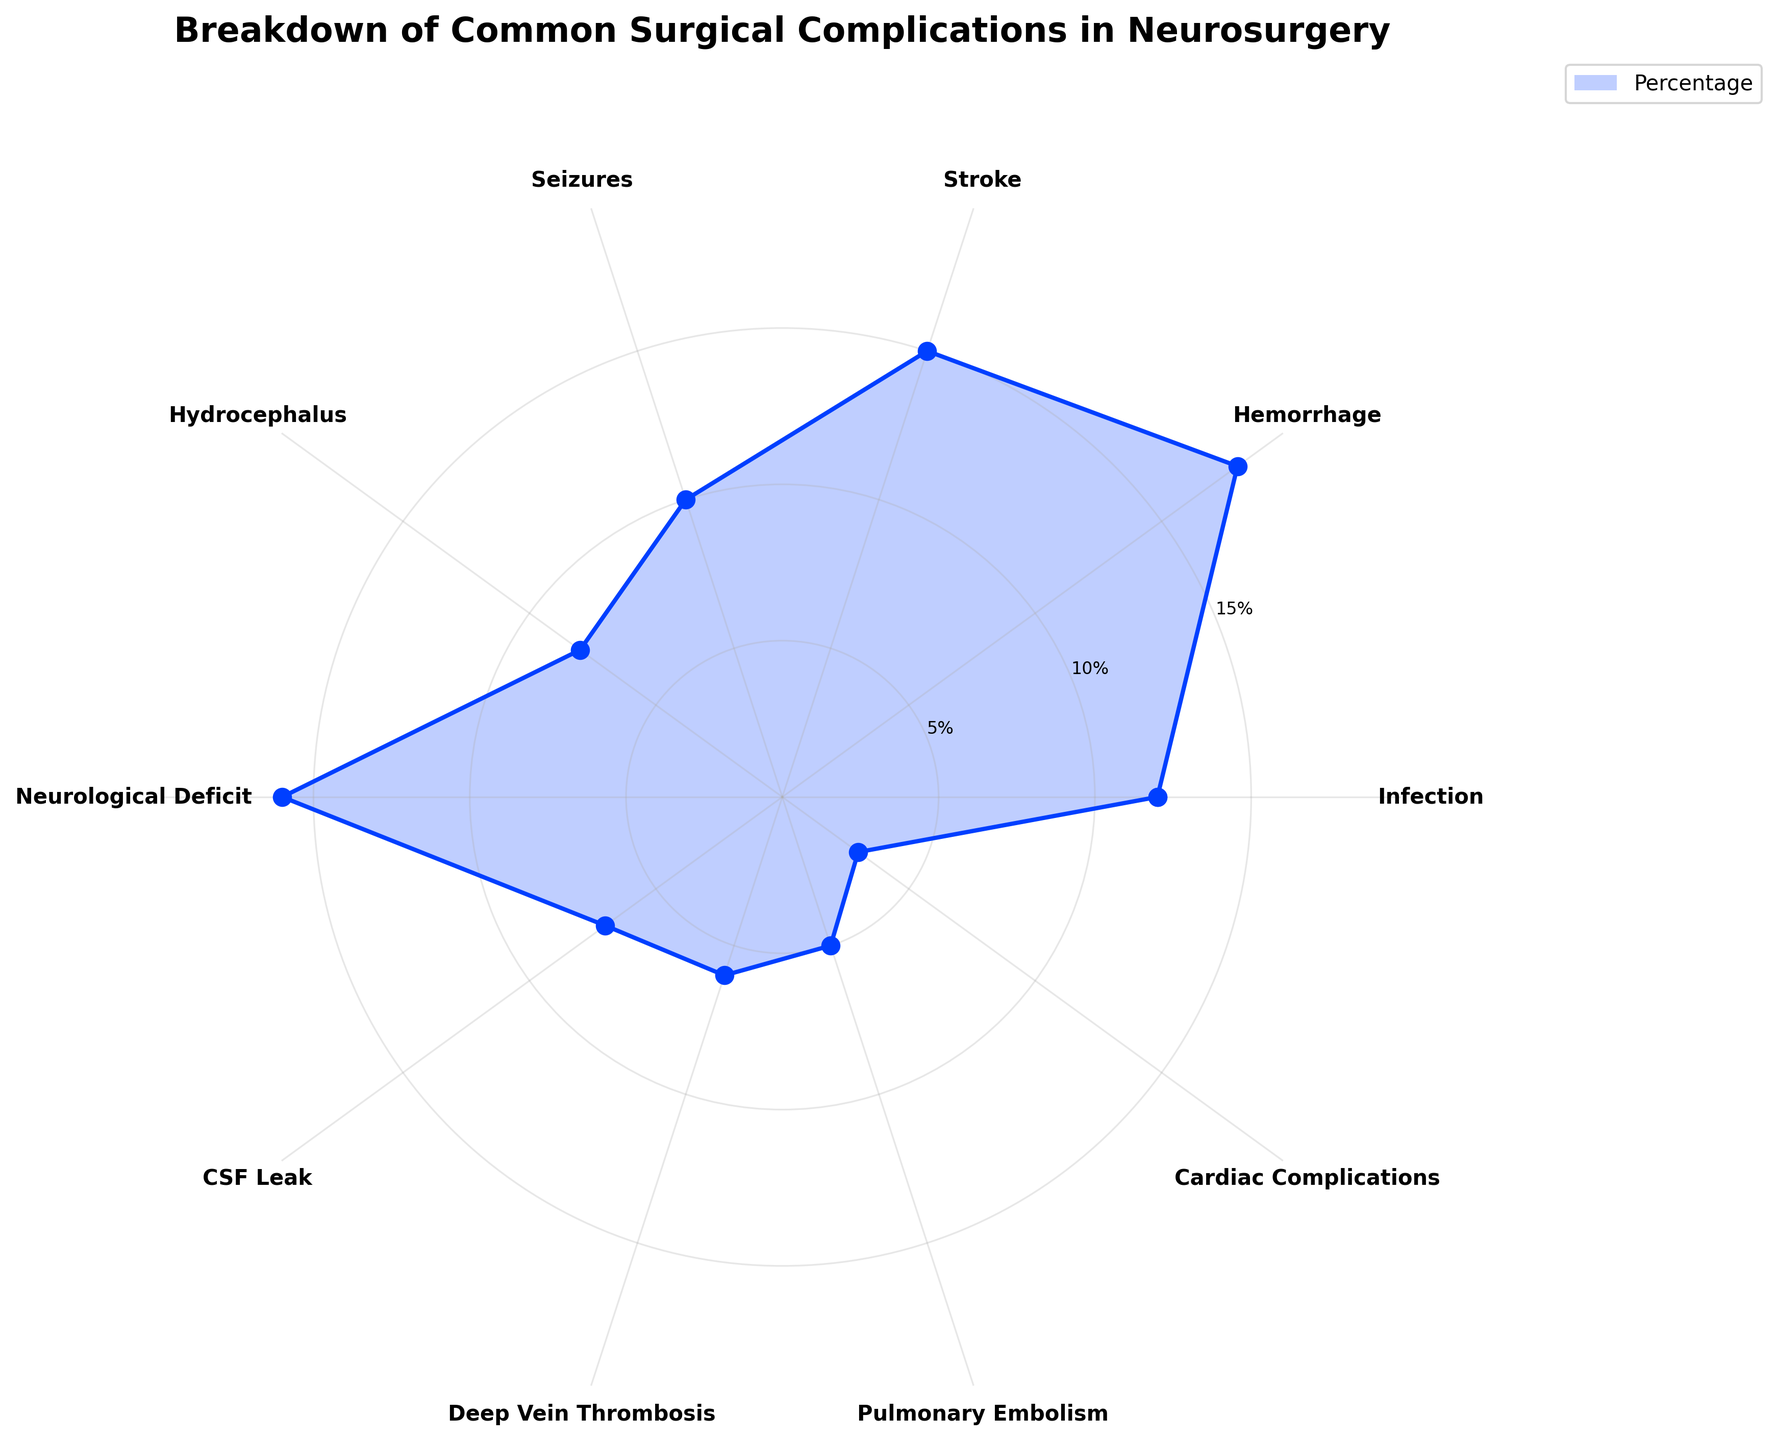What is the largest category of common surgical complications in neurosurgery? The largest category can be identified by scanning the plot for the highest percentage value. Hemorrhage has the highest value at 18%.
Answer: Hemorrhage Which complication has the lowest percentage as shown in the polar area chart? By looking for the smallest slice of the chart, we see that Cardiac Complications have the lowest percentage at 3%.
Answer: Cardiac Complications What is the total percentage of complications caused by Stroke and Neurological Deficit? To find the combined percentage, add the values for Stroke (15%) and Neurological Deficit (16%). 15% + 16% = 31%.
Answer: 31% How does the percentage of Seizures compare to that of Hydrocephalus? We compare the given percentages of Seizures (10%) and Hydrocephalus (8%). Since 10% is greater than 8%, Seizures have a higher percentage.
Answer: Seizures is higher What is the average percentage of complications for the top three categories? First, identify the top three percentages: Hemorrhage (18%), Neurological Deficit (16%), and Stroke (15%). Then calculate the average: (18% + 16% + 15%) / 3 = 16.33%.
Answer: 16.33% Which complication categories lie within the 5% to 10% range? Scan the chart for percentages within this range: 7% for CSF Leak, 6% for Deep Vein Thrombosis, 8% for Hydrocephalus, and 5% for Pulmonary Embolism.
Answer: CSF Leak, Deep Vein Thrombosis, Hydrocephalus, and Pulmonary Embolism What proportion of total complications is due to Infection, Pulmonary Embolism, and Cardiac Complications combined? Sum the percentages of Infection (12%), Pulmonary Embolism (5%), and Cardiac Complications (3%): 12% + 5% + 3% = 20%.
Answer: 20% Which complication is exactly in the middle when complications are ranked by percentage? Rank the complications from highest to lowest. The median complication (5th in a list of 10) is Hydrocephalus at 8%.
Answer: Hydrocephalus What is the difference in percentage between the highest and lowest complication categories? Calculate the difference between Hemorrhage (18%) and Cardiac Complications (3%): 18% - 3% = 15%.
Answer: 15% 